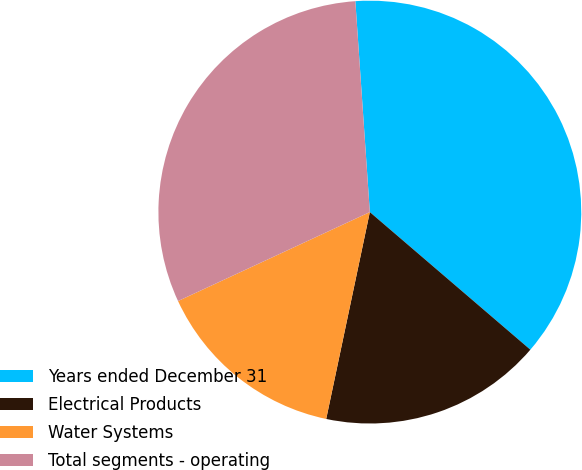Convert chart. <chart><loc_0><loc_0><loc_500><loc_500><pie_chart><fcel>Years ended December 31<fcel>Electrical Products<fcel>Water Systems<fcel>Total segments - operating<nl><fcel>37.37%<fcel>17.03%<fcel>14.78%<fcel>30.82%<nl></chart> 